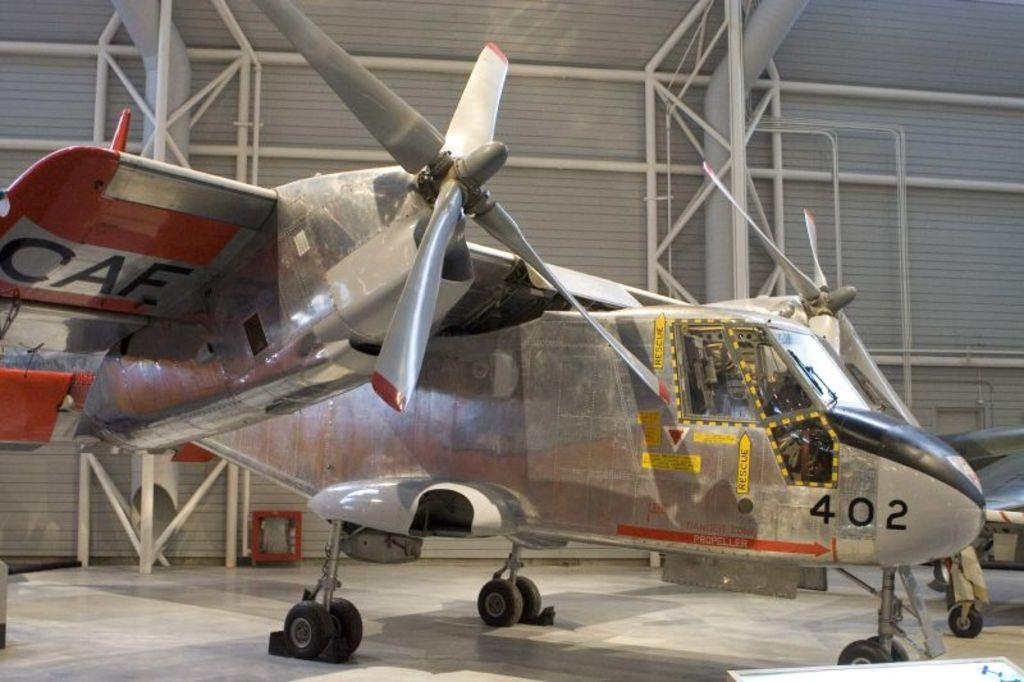<image>
Describe the image concisely. A silver CAF plane sitting inside an aircraft hanger with the number 402. 